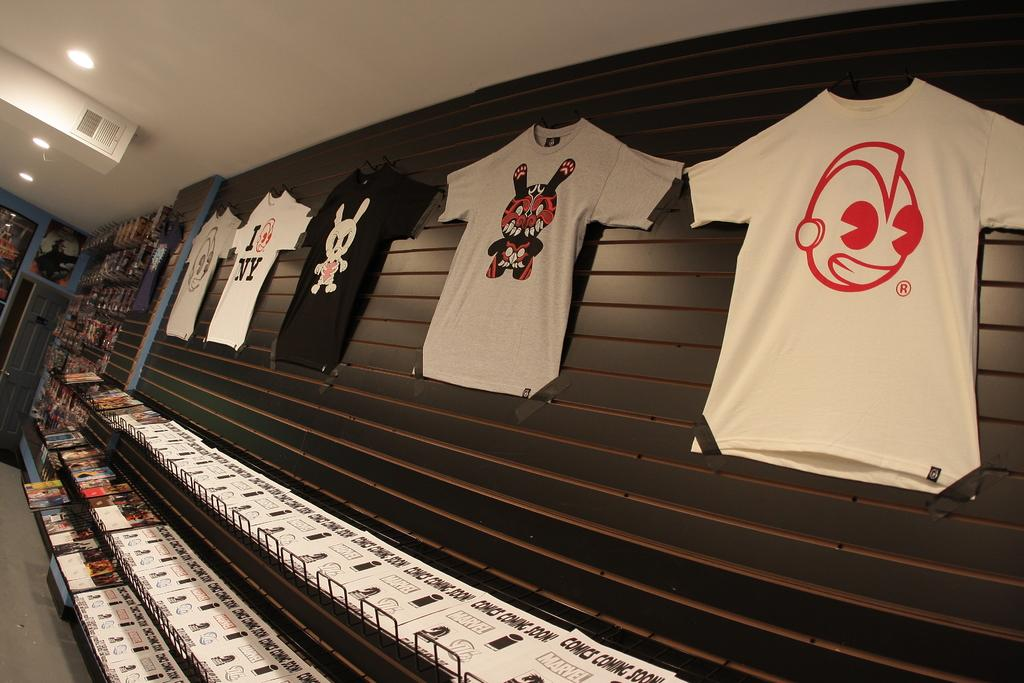What is on the racks in the image? There are papers and objects on the racks in the image. What is hanging on the wall in the image? There are t-shirts on the wall in the image. What can be seen in the background of the image? In the background, there are objects on the racks and lights on the ceiling. How many feet are visible in the image? There are no feet visible in the image. Is there a hole in the wall in the image? There is no hole in the wall in the image. 